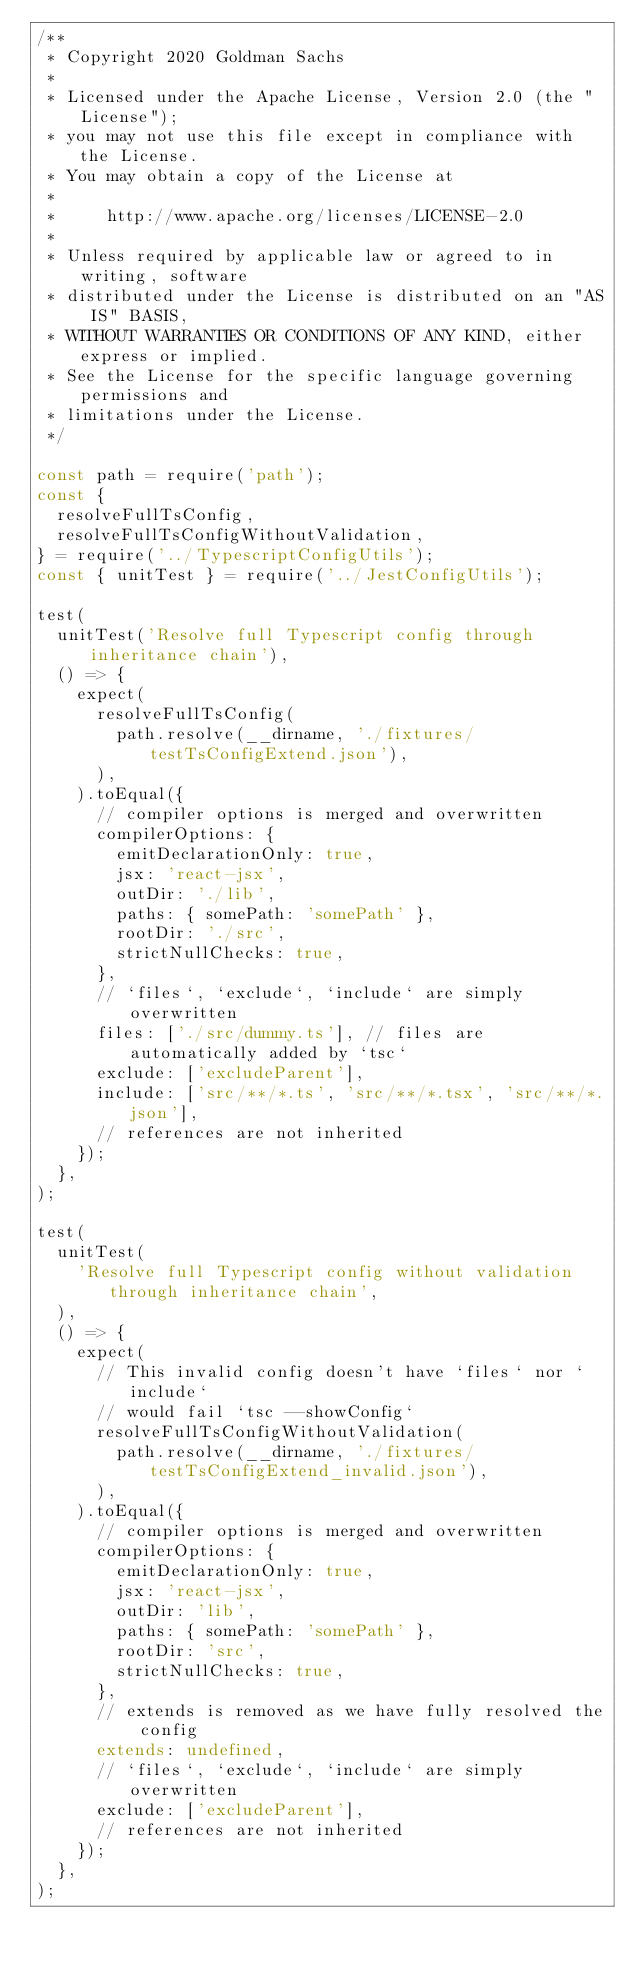<code> <loc_0><loc_0><loc_500><loc_500><_JavaScript_>/**
 * Copyright 2020 Goldman Sachs
 *
 * Licensed under the Apache License, Version 2.0 (the "License");
 * you may not use this file except in compliance with the License.
 * You may obtain a copy of the License at
 *
 *     http://www.apache.org/licenses/LICENSE-2.0
 *
 * Unless required by applicable law or agreed to in writing, software
 * distributed under the License is distributed on an "AS IS" BASIS,
 * WITHOUT WARRANTIES OR CONDITIONS OF ANY KIND, either express or implied.
 * See the License for the specific language governing permissions and
 * limitations under the License.
 */

const path = require('path');
const {
  resolveFullTsConfig,
  resolveFullTsConfigWithoutValidation,
} = require('../TypescriptConfigUtils');
const { unitTest } = require('../JestConfigUtils');

test(
  unitTest('Resolve full Typescript config through inheritance chain'),
  () => {
    expect(
      resolveFullTsConfig(
        path.resolve(__dirname, './fixtures/testTsConfigExtend.json'),
      ),
    ).toEqual({
      // compiler options is merged and overwritten
      compilerOptions: {
        emitDeclarationOnly: true,
        jsx: 'react-jsx',
        outDir: './lib',
        paths: { somePath: 'somePath' },
        rootDir: './src',
        strictNullChecks: true,
      },
      // `files`, `exclude`, `include` are simply overwritten
      files: ['./src/dummy.ts'], // files are automatically added by `tsc`
      exclude: ['excludeParent'],
      include: ['src/**/*.ts', 'src/**/*.tsx', 'src/**/*.json'],
      // references are not inherited
    });
  },
);

test(
  unitTest(
    'Resolve full Typescript config without validation through inheritance chain',
  ),
  () => {
    expect(
      // This invalid config doesn't have `files` nor `include`
      // would fail `tsc --showConfig`
      resolveFullTsConfigWithoutValidation(
        path.resolve(__dirname, './fixtures/testTsConfigExtend_invalid.json'),
      ),
    ).toEqual({
      // compiler options is merged and overwritten
      compilerOptions: {
        emitDeclarationOnly: true,
        jsx: 'react-jsx',
        outDir: 'lib',
        paths: { somePath: 'somePath' },
        rootDir: 'src',
        strictNullChecks: true,
      },
      // extends is removed as we have fully resolved the config
      extends: undefined,
      // `files`, `exclude`, `include` are simply overwritten
      exclude: ['excludeParent'],
      // references are not inherited
    });
  },
);
</code> 